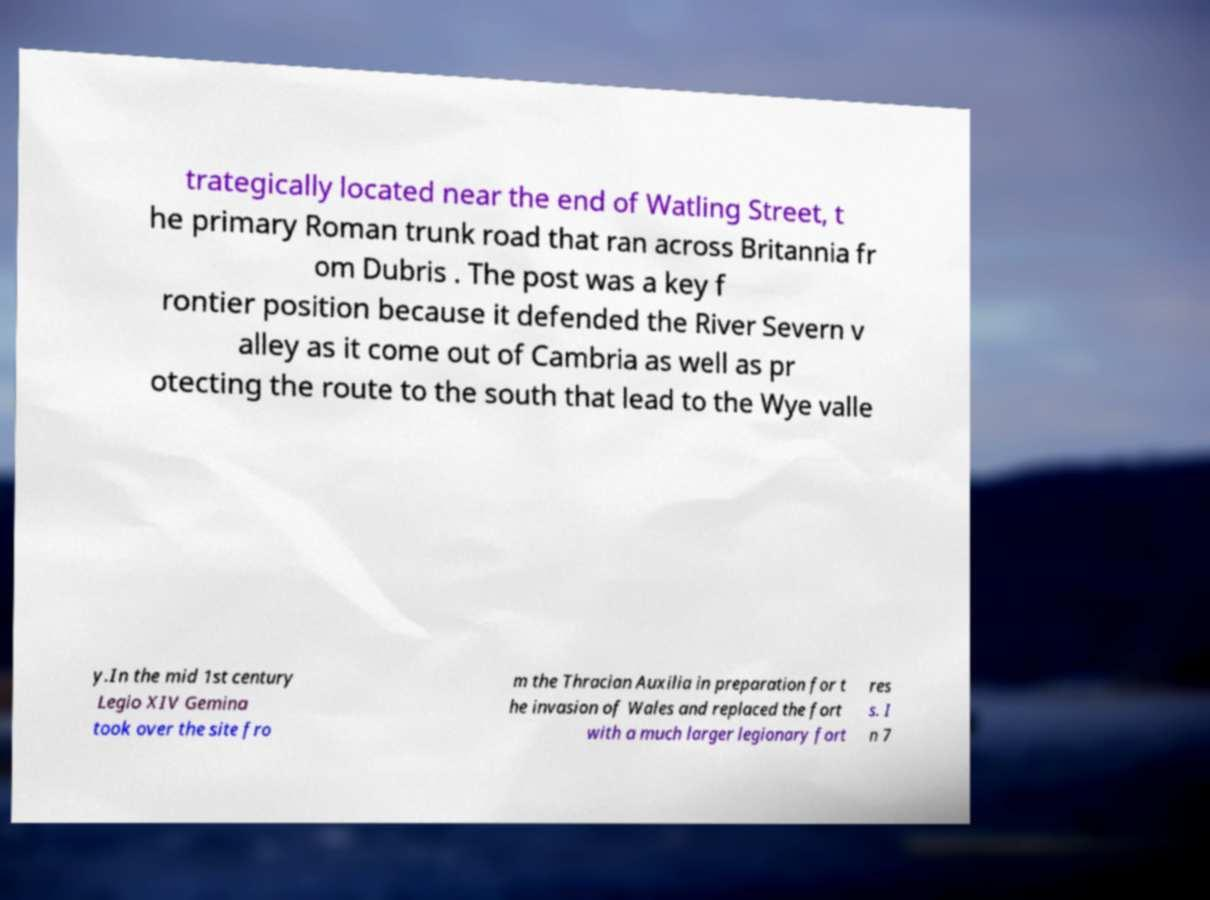For documentation purposes, I need the text within this image transcribed. Could you provide that? trategically located near the end of Watling Street, t he primary Roman trunk road that ran across Britannia fr om Dubris . The post was a key f rontier position because it defended the River Severn v alley as it come out of Cambria as well as pr otecting the route to the south that lead to the Wye valle y.In the mid 1st century Legio XIV Gemina took over the site fro m the Thracian Auxilia in preparation for t he invasion of Wales and replaced the fort with a much larger legionary fort res s. I n 7 